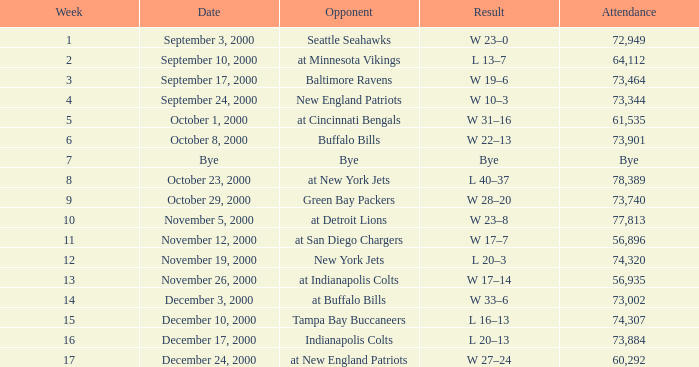What is the conclusion of the game with 72,949 present? W 23–0. 